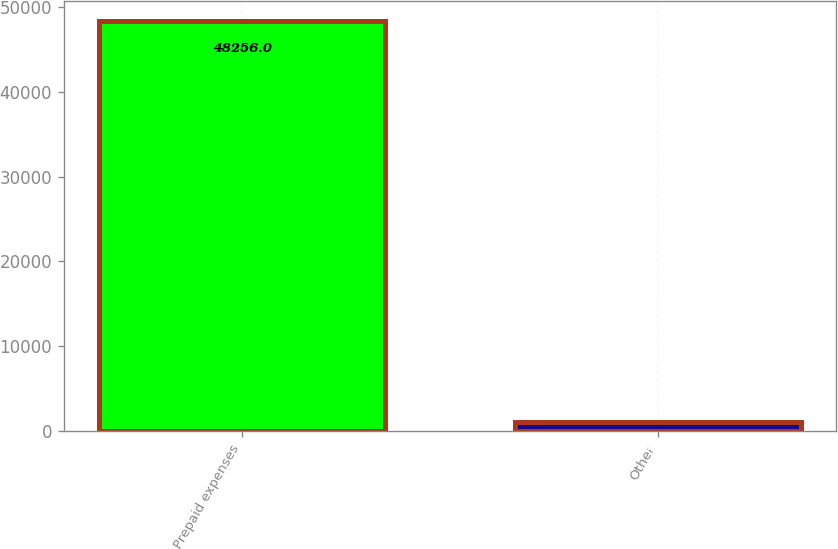Convert chart to OTSL. <chart><loc_0><loc_0><loc_500><loc_500><bar_chart><fcel>Prepaid expenses<fcel>Other<nl><fcel>48256<fcel>1093<nl></chart> 